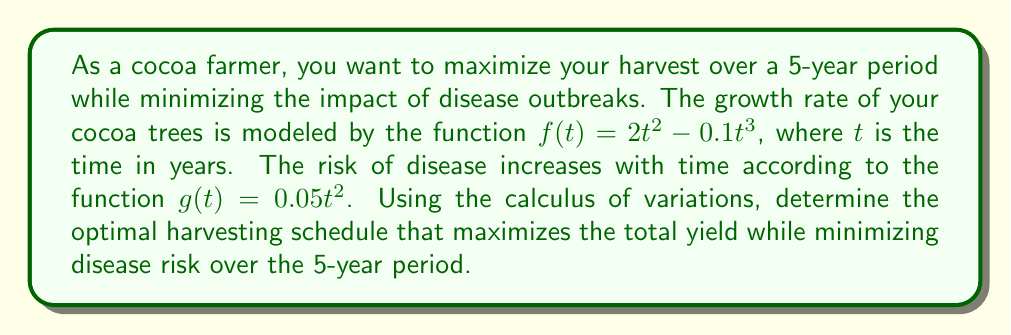Help me with this question. To solve this problem using calculus of variations, we need to:

1. Define the functional to be optimized:
   $$J[y] = \int_0^5 (f(t) - g(t))y(t)dt = \int_0^5 (2t^2 - 0.1t^3 - 0.05t^2)y(t)dt$$
   where $y(t)$ is the harvesting rate at time $t$.

2. Apply the Euler-Lagrange equation:
   $$\frac{\partial F}{\partial y} - \frac{d}{dt}\left(\frac{\partial F}{\partial y'}\right) = 0$$
   where $F = (2t^2 - 0.1t^3 - 0.05t^2)y(t)$

3. Solve the Euler-Lagrange equation:
   $$2t^2 - 0.1t^3 - 0.05t^2 = 0$$
   $$1.95t^2 - 0.1t^3 = 0$$
   $$t^2(1.95 - 0.1t) = 0$$

4. Find the critical points:
   $t = 0$ or $t = 19.5$

5. Analyze the results:
   - $t = 0$ is the start of the period and doesn't provide useful information.
   - $t = 19.5$ is outside our 5-year period.

6. Conclude:
   Since there are no critical points within our time frame, the optimal harvesting schedule is to harvest at the boundaries of the time interval:
   - Harvest maximally at $t = 0$ (beginning of the period)
   - Harvest maximally at $t = 5$ (end of the period)
   - Minimal or no harvesting in between these times

This schedule maximizes yield at the beginning when disease risk is low and at the end to collect remaining yield before the period ends, while minimizing exposure to increasing disease risk in the middle years.
Answer: Harvest maximally at $t = 0$ and $t = 5$, minimally in between. 